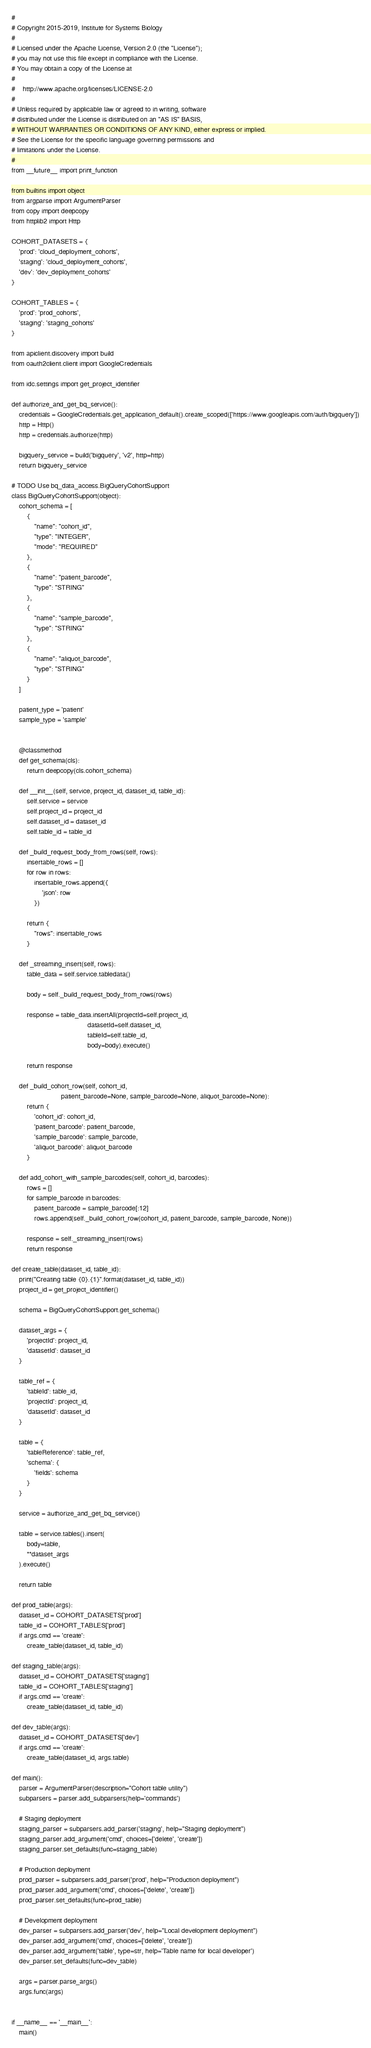<code> <loc_0><loc_0><loc_500><loc_500><_Python_>#
# Copyright 2015-2019, Institute for Systems Biology
#
# Licensed under the Apache License, Version 2.0 (the "License");
# you may not use this file except in compliance with the License.
# You may obtain a copy of the License at
#
#    http://www.apache.org/licenses/LICENSE-2.0
#
# Unless required by applicable law or agreed to in writing, software
# distributed under the License is distributed on an "AS IS" BASIS,
# WITHOUT WARRANTIES OR CONDITIONS OF ANY KIND, either express or implied.
# See the License for the specific language governing permissions and
# limitations under the License.
#
from __future__ import print_function

from builtins import object
from argparse import ArgumentParser
from copy import deepcopy
from httplib2 import Http

COHORT_DATASETS = {
    'prod': 'cloud_deployment_cohorts',
    'staging': 'cloud_deployment_cohorts',
    'dev': 'dev_deployment_cohorts'
}

COHORT_TABLES = {
    'prod': 'prod_cohorts',
    'staging': 'staging_cohorts'
}

from apiclient.discovery import build
from oauth2client.client import GoogleCredentials

from idc.settings import get_project_identifier

def authorize_and_get_bq_service():
    credentials = GoogleCredentials.get_application_default().create_scoped(['https://www.googleapis.com/auth/bigquery'])
    http = Http()
    http = credentials.authorize(http)

    bigquery_service = build('bigquery', 'v2', http=http)
    return bigquery_service

# TODO Use bq_data_access.BigQueryCohortSupport
class BigQueryCohortSupport(object):
    cohort_schema = [
        {
            "name": "cohort_id",
            "type": "INTEGER",
            "mode": "REQUIRED"
        },
        {
            "name": "patient_barcode",
            "type": "STRING"
        },
        {
            "name": "sample_barcode",
            "type": "STRING"
        },
        {
            "name": "aliquot_barcode",
            "type": "STRING"
        }
    ]

    patient_type = 'patient'
    sample_type = 'sample'


    @classmethod
    def get_schema(cls):
        return deepcopy(cls.cohort_schema)

    def __init__(self, service, project_id, dataset_id, table_id):
        self.service = service
        self.project_id = project_id
        self.dataset_id = dataset_id
        self.table_id = table_id

    def _build_request_body_from_rows(self, rows):
        insertable_rows = []
        for row in rows:
            insertable_rows.append({
                'json': row
            })

        return {
            "rows": insertable_rows
        }

    def _streaming_insert(self, rows):
        table_data = self.service.tabledata()

        body = self._build_request_body_from_rows(rows)

        response = table_data.insertAll(projectId=self.project_id,
                                        datasetId=self.dataset_id,
                                        tableId=self.table_id,
                                        body=body).execute()

        return response

    def _build_cohort_row(self, cohort_id,
                          patient_barcode=None, sample_barcode=None, aliquot_barcode=None):
        return {
            'cohort_id': cohort_id,
            'patient_barcode': patient_barcode,
            'sample_barcode': sample_barcode,
            'aliquot_barcode': aliquot_barcode
        }

    def add_cohort_with_sample_barcodes(self, cohort_id, barcodes):
        rows = []
        for sample_barcode in barcodes:
            patient_barcode = sample_barcode[:12]
            rows.append(self._build_cohort_row(cohort_id, patient_barcode, sample_barcode, None))

        response = self._streaming_insert(rows)
        return response

def create_table(dataset_id, table_id):
    print("Creating table {0}.{1}".format(dataset_id, table_id))
    project_id = get_project_identifier()

    schema = BigQueryCohortSupport.get_schema()

    dataset_args = {
        'projectId': project_id,
        'datasetId': dataset_id
    }

    table_ref = {
        'tableId': table_id,
        'projectId': project_id,
        'datasetId': dataset_id
    }

    table = {
        'tableReference': table_ref,
        'schema': {
            'fields': schema
        }
    }

    service = authorize_and_get_bq_service()

    table = service.tables().insert(
        body=table,
        **dataset_args
    ).execute()

    return table

def prod_table(args):
    dataset_id = COHORT_DATASETS['prod']
    table_id = COHORT_TABLES['prod']
    if args.cmd == 'create':
        create_table(dataset_id, table_id)

def staging_table(args):
    dataset_id = COHORT_DATASETS['staging']
    table_id = COHORT_TABLES['staging']
    if args.cmd == 'create':
        create_table(dataset_id, table_id)

def dev_table(args):
    dataset_id = COHORT_DATASETS['dev']
    if args.cmd == 'create':
        create_table(dataset_id, args.table)

def main():
    parser = ArgumentParser(description="Cohort table utility")
    subparsers = parser.add_subparsers(help='commands')

    # Staging deployment
    staging_parser = subparsers.add_parser('staging', help="Staging deployment")
    staging_parser.add_argument('cmd', choices=['delete', 'create'])
    staging_parser.set_defaults(func=staging_table)

    # Production deployment
    prod_parser = subparsers.add_parser('prod', help="Production deployment")
    prod_parser.add_argument('cmd', choices=['delete', 'create'])
    prod_parser.set_defaults(func=prod_table)

    # Development deployment
    dev_parser = subparsers.add_parser('dev', help="Local development deployment")
    dev_parser.add_argument('cmd', choices=['delete', 'create'])
    dev_parser.add_argument('table', type=str, help='Table name for local developer')
    dev_parser.set_defaults(func=dev_table)

    args = parser.parse_args()
    args.func(args)


if __name__ == '__main__':
    main()
</code> 